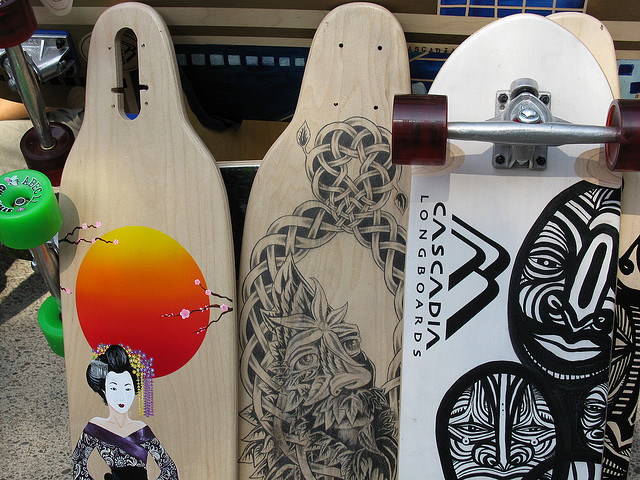Please transcribe the text information in this image. LONG BOARDS LONG BOARDS ABECLI 